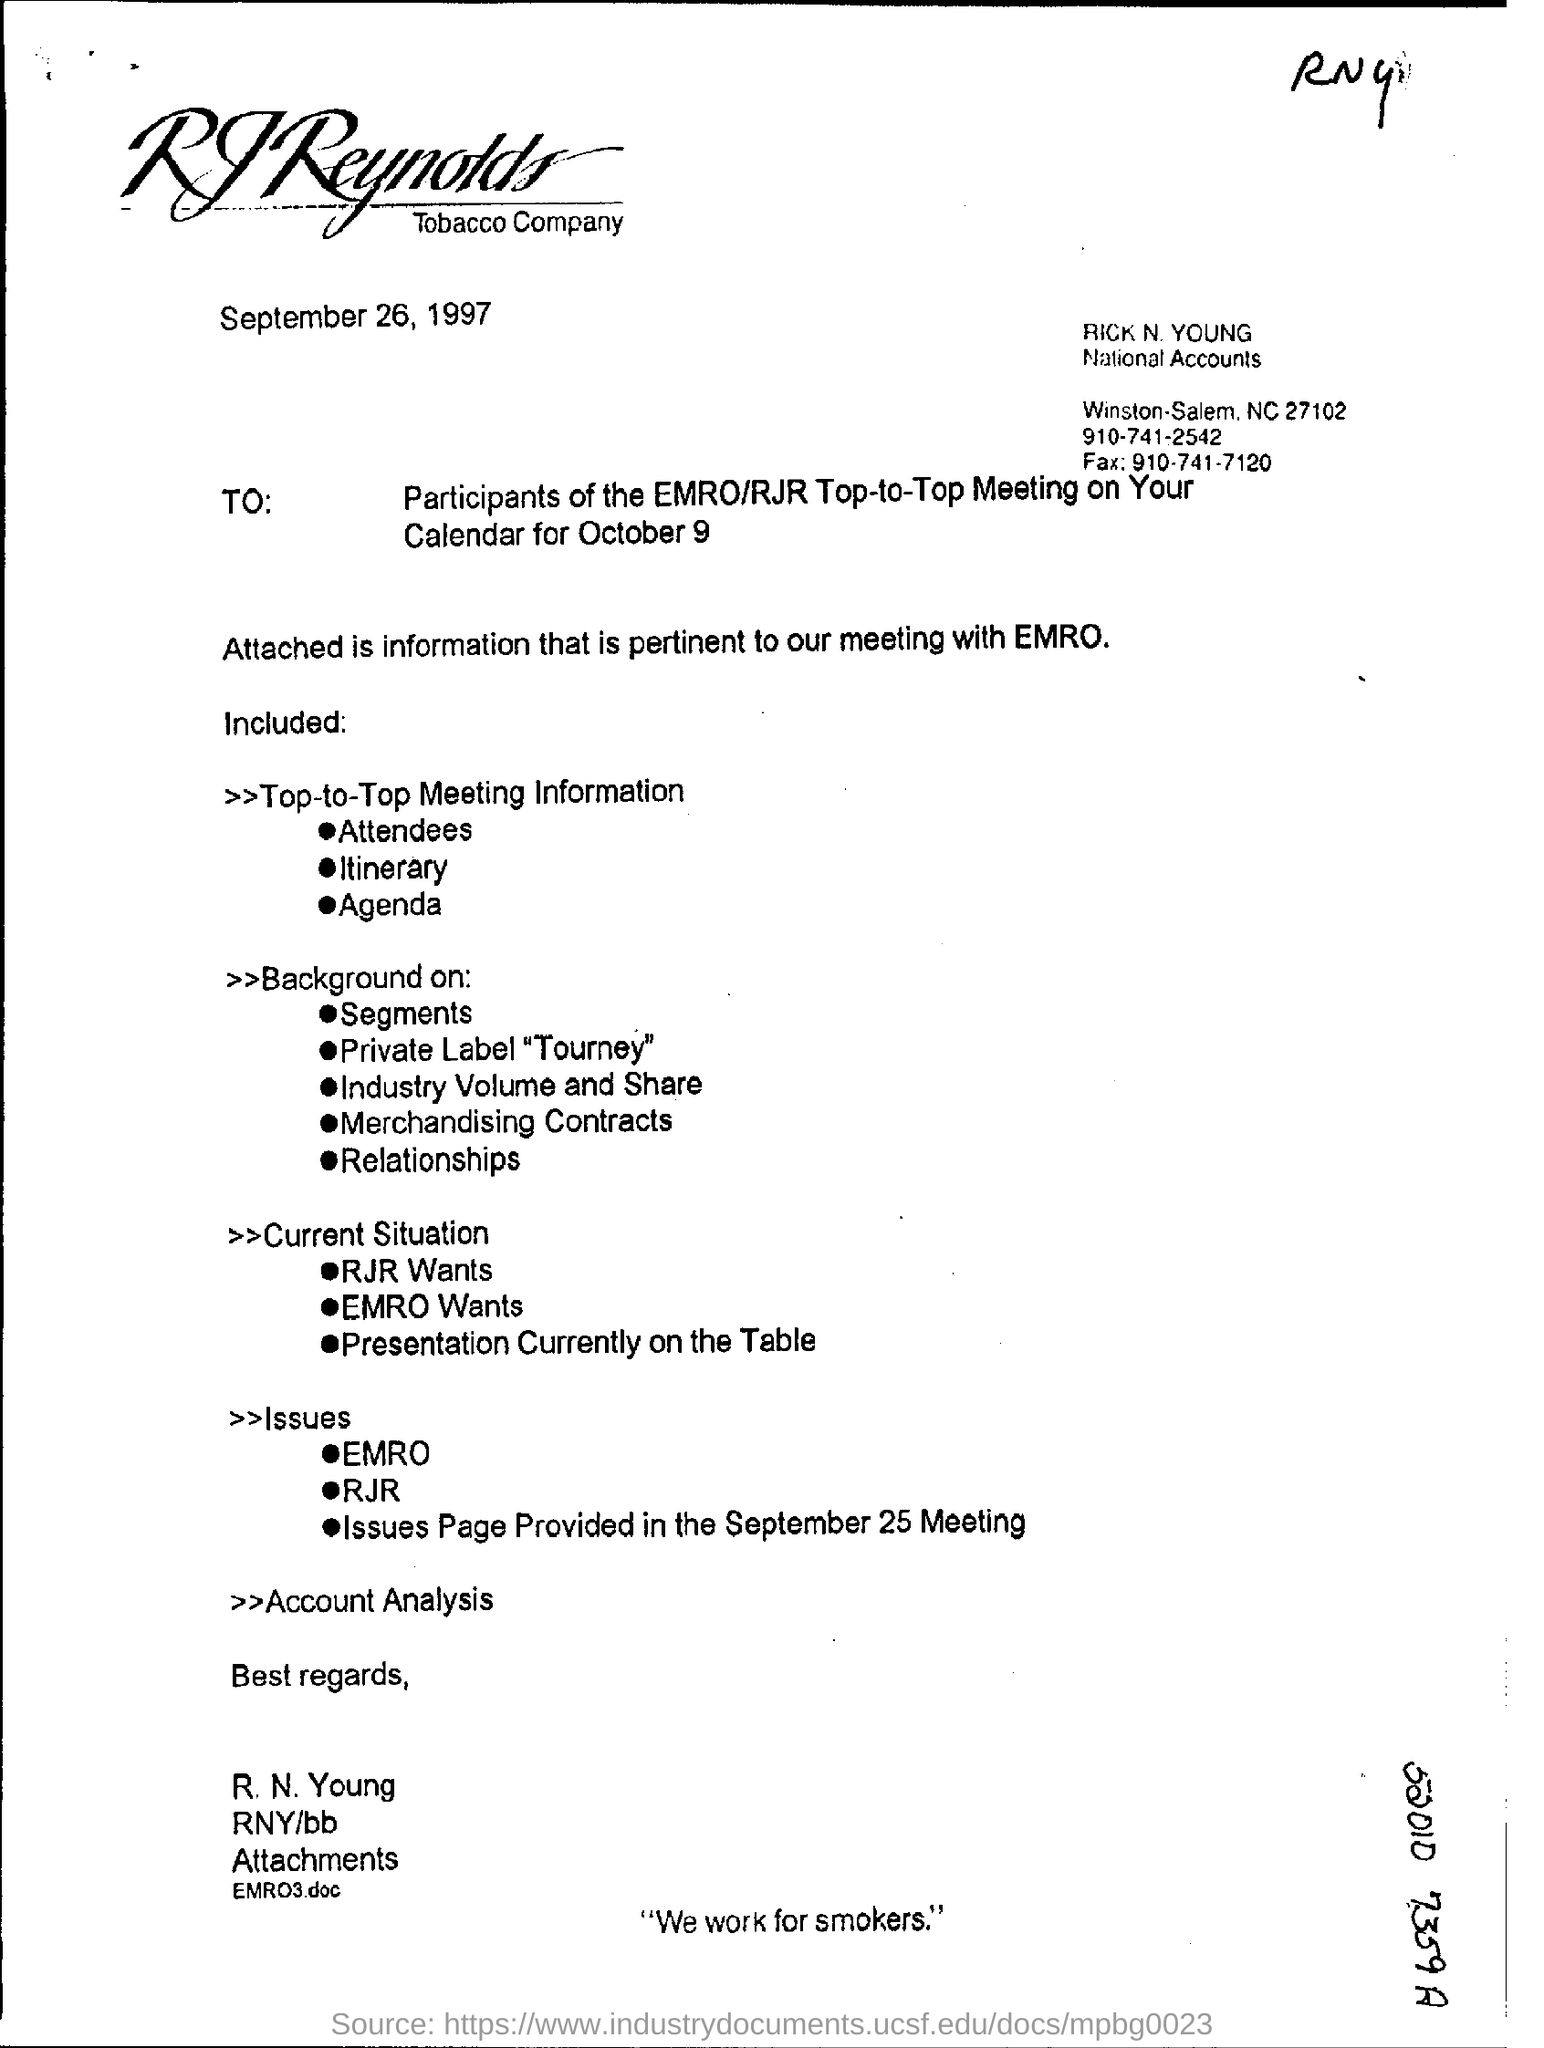Mention a couple of crucial points in this snapshot. The date mentioned at the top of the document is September 26, 1997. The date mentioned in the document is September 26, 1997. The fax number is 910-741-7120. 